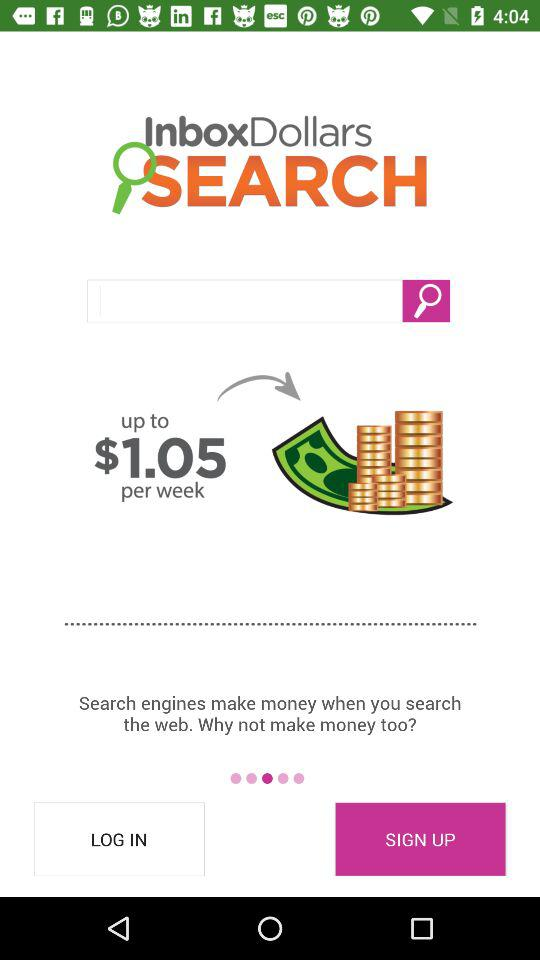What are the log-in requirements?
When the provided information is insufficient, respond with <no answer>. <no answer> 